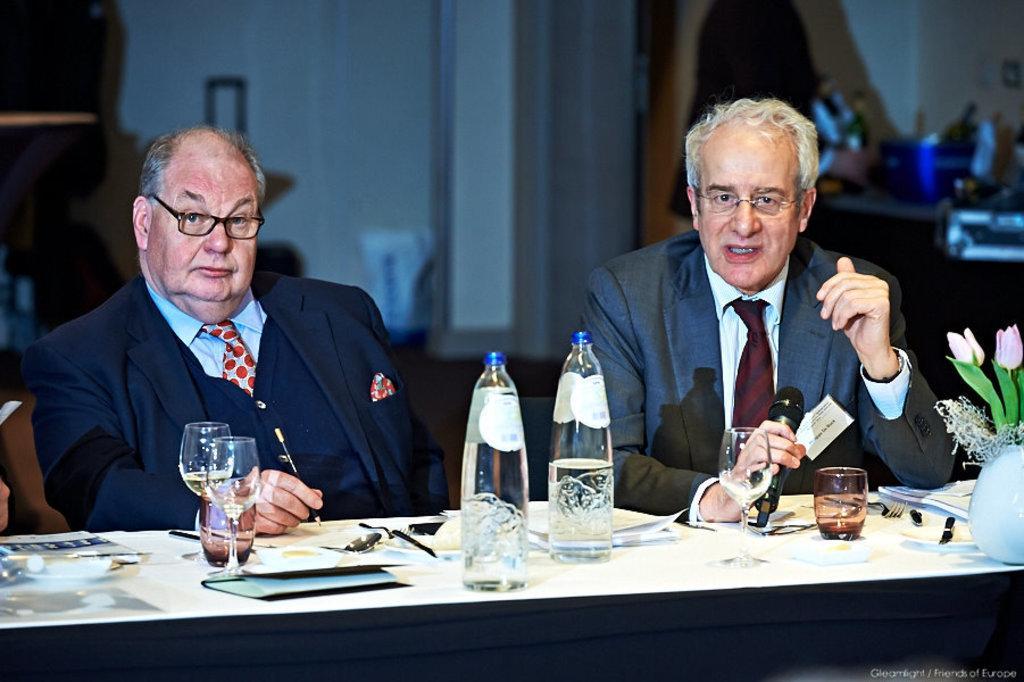How would you summarize this image in a sentence or two? In this image I can see two people are sitting and one person is holding something and another person is holding the mic. I can see few bottles, glasses, flowerpot and few objects on the table. In the background I can see few objects and the wall. 